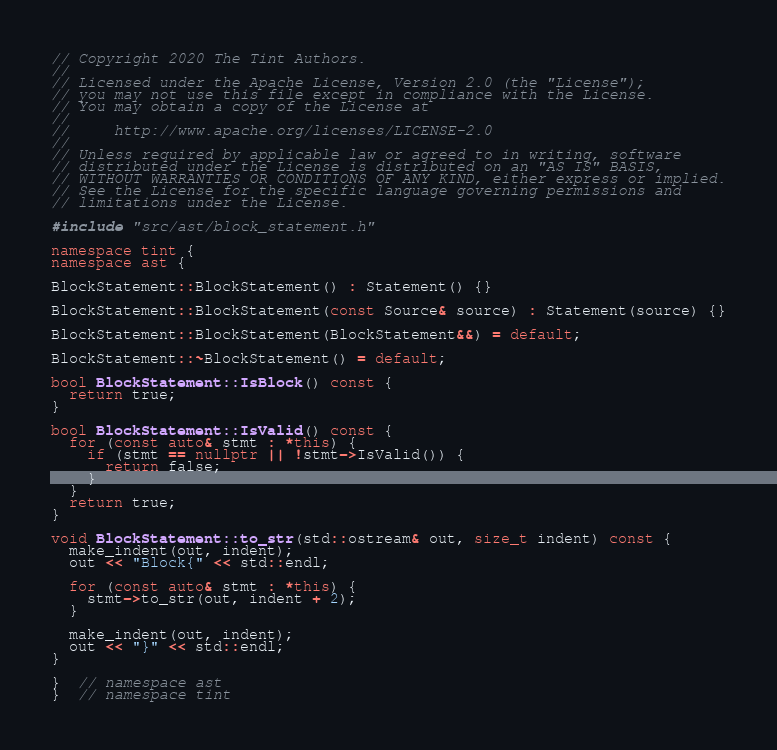Convert code to text. <code><loc_0><loc_0><loc_500><loc_500><_C++_>// Copyright 2020 The Tint Authors.
//
// Licensed under the Apache License, Version 2.0 (the "License");
// you may not use this file except in compliance with the License.
// You may obtain a copy of the License at
//
//     http://www.apache.org/licenses/LICENSE-2.0
//
// Unless required by applicable law or agreed to in writing, software
// distributed under the License is distributed on an "AS IS" BASIS,
// WITHOUT WARRANTIES OR CONDITIONS OF ANY KIND, either express or implied.
// See the License for the specific language governing permissions and
// limitations under the License.

#include "src/ast/block_statement.h"

namespace tint {
namespace ast {

BlockStatement::BlockStatement() : Statement() {}

BlockStatement::BlockStatement(const Source& source) : Statement(source) {}

BlockStatement::BlockStatement(BlockStatement&&) = default;

BlockStatement::~BlockStatement() = default;

bool BlockStatement::IsBlock() const {
  return true;
}

bool BlockStatement::IsValid() const {
  for (const auto& stmt : *this) {
    if (stmt == nullptr || !stmt->IsValid()) {
      return false;
    }
  }
  return true;
}

void BlockStatement::to_str(std::ostream& out, size_t indent) const {
  make_indent(out, indent);
  out << "Block{" << std::endl;

  for (const auto& stmt : *this) {
    stmt->to_str(out, indent + 2);
  }

  make_indent(out, indent);
  out << "}" << std::endl;
}

}  // namespace ast
}  // namespace tint
</code> 